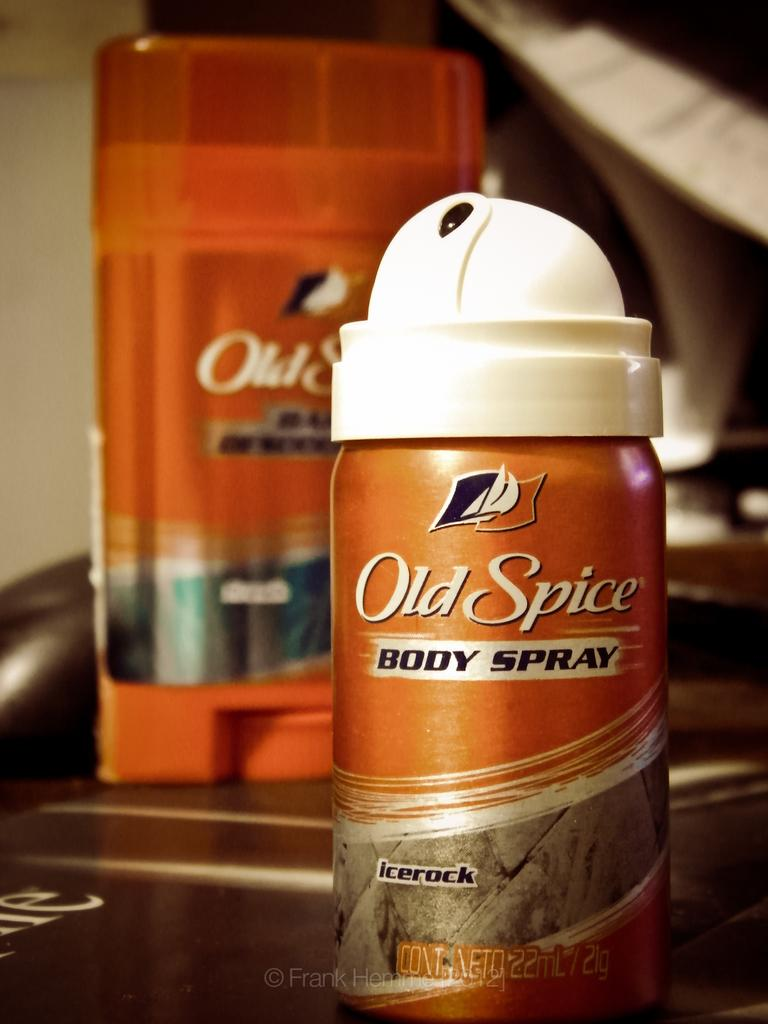Provide a one-sentence caption for the provided image. Old Spice Body Spray comes in the fragrance 'icerock'. 